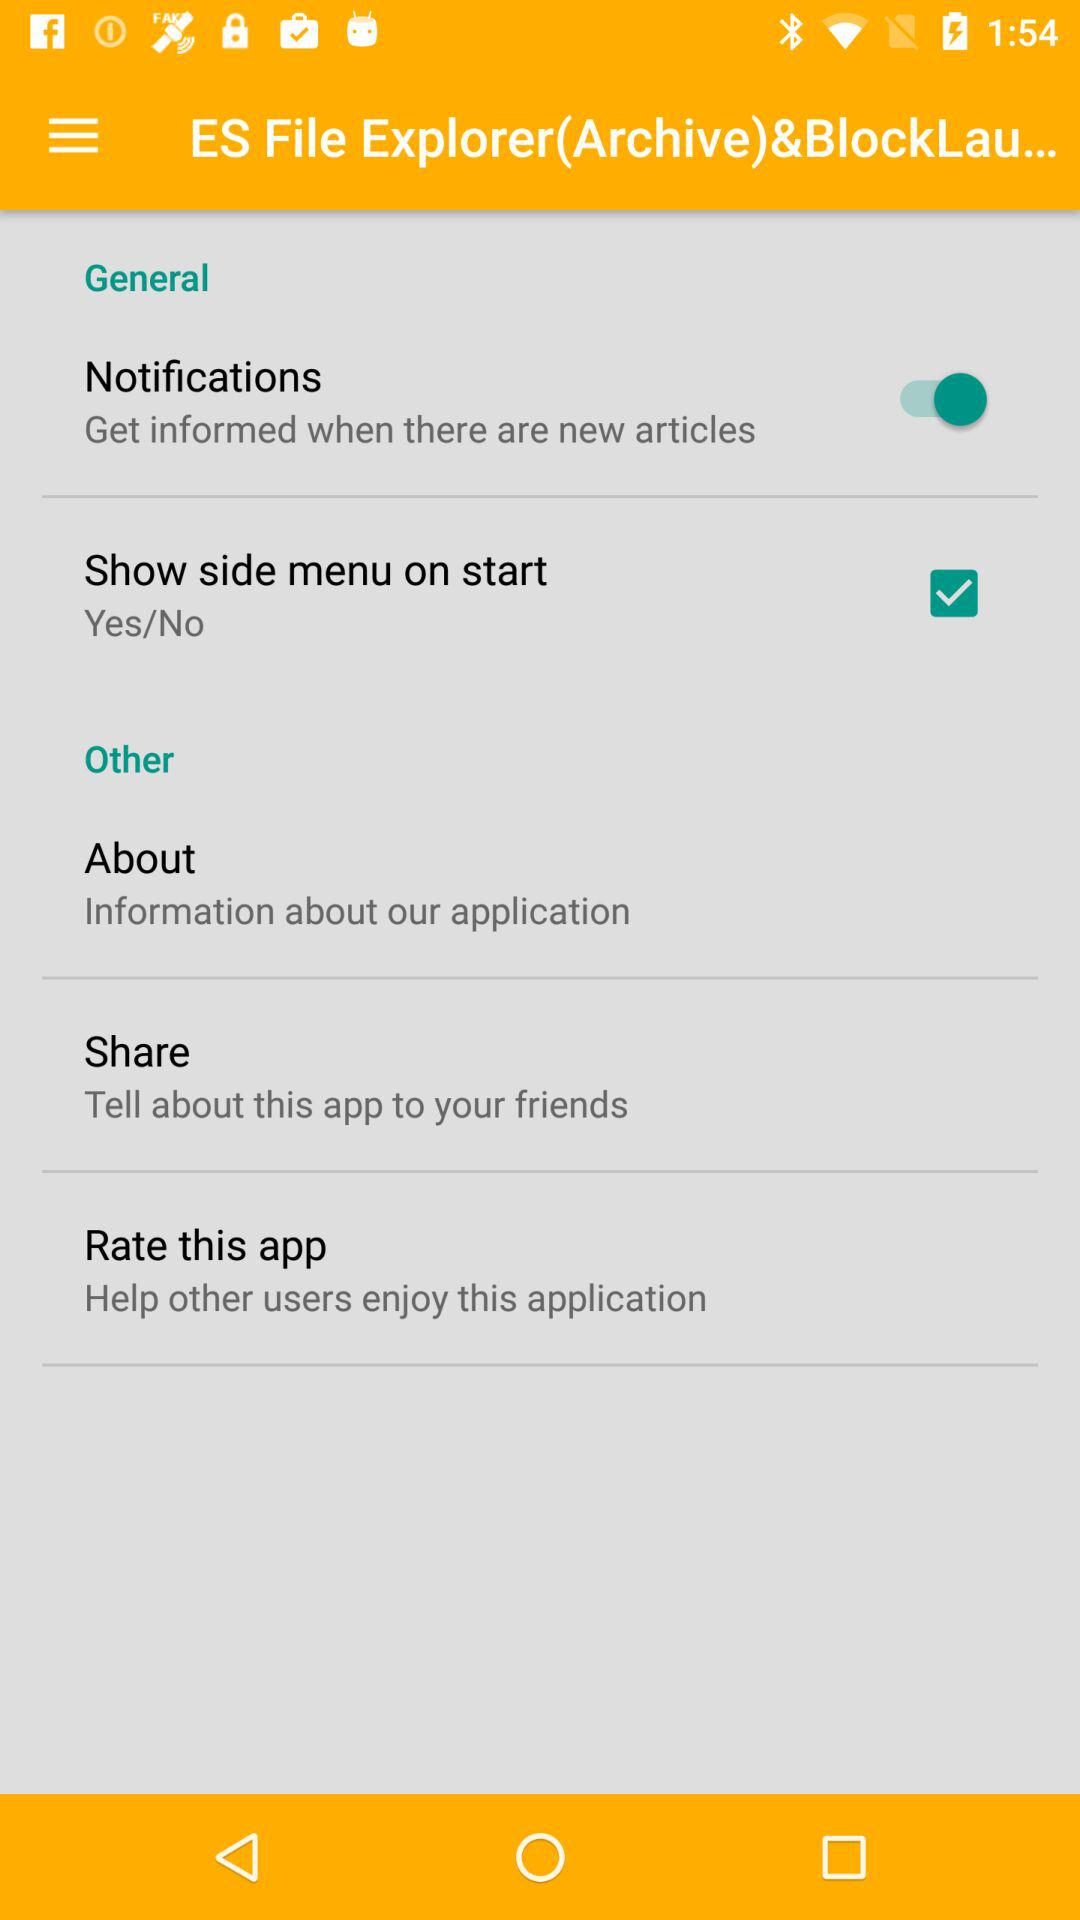What is the status of "Notifications"? The status is "on". 